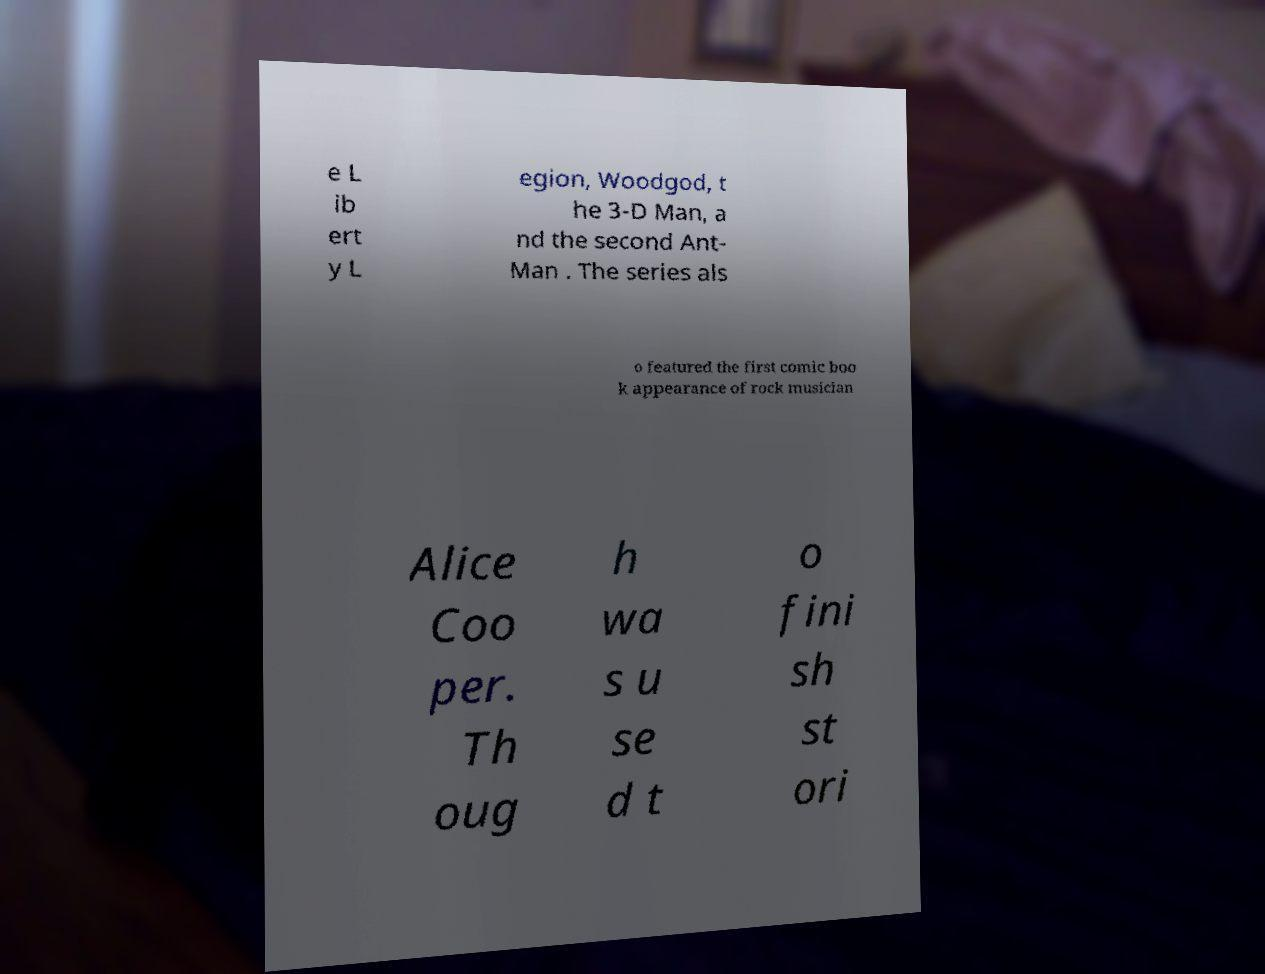I need the written content from this picture converted into text. Can you do that? e L ib ert y L egion, Woodgod, t he 3-D Man, a nd the second Ant- Man . The series als o featured the first comic boo k appearance of rock musician Alice Coo per. Th oug h wa s u se d t o fini sh st ori 